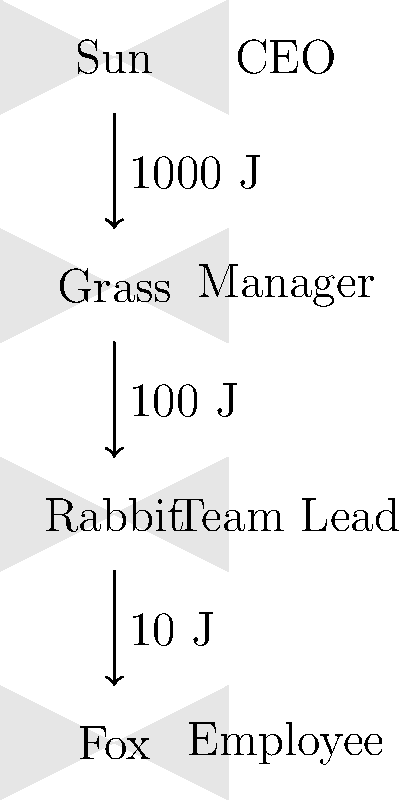In the energy transfer diagram above, represented as a corporate hierarchy, what percentage of the initial energy from the Sun (CEO level) is available to the Fox (Employee level) in this simplified food chain? To solve this problem, we need to follow the energy transfer through each level of the food chain, which is represented as a corporate hierarchy:

1. The Sun (CEO) provides 1000 J of initial energy.

2. The energy transfer to Grass (Manager) is 100 J.
   Energy efficiency: $\frac{100 J}{1000 J} \times 100\% = 10\%$

3. The energy transfer to Rabbit (Team Lead) is 10 J.
   Energy efficiency: $\frac{10 J}{100 J} \times 100\% = 10\%$

4. The energy transfer to Fox (Employee) is 1 J.
   Energy efficiency: $\frac{1 J}{10 J} \times 100\% = 10\%$

5. To calculate the overall percentage of initial energy available to the Fox:
   $\frac{1 J}{1000 J} \times 100\% = 0.1\%$

Therefore, 0.1% of the initial energy from the Sun (CEO) is available to the Fox (Employee) in this simplified food chain.
Answer: 0.1% 